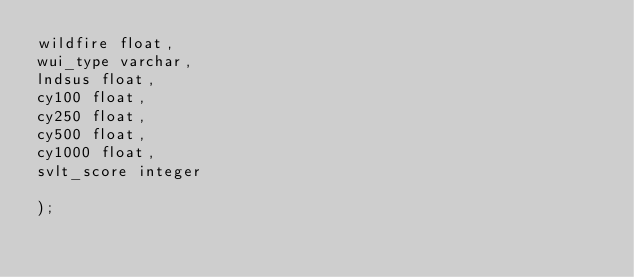<code> <loc_0><loc_0><loc_500><loc_500><_SQL_>wildfire float,
wui_type varchar,
lndsus float,
cy100 float,
cy250 float,
cy500 float,
cy1000 float,
svlt_score integer

);</code> 